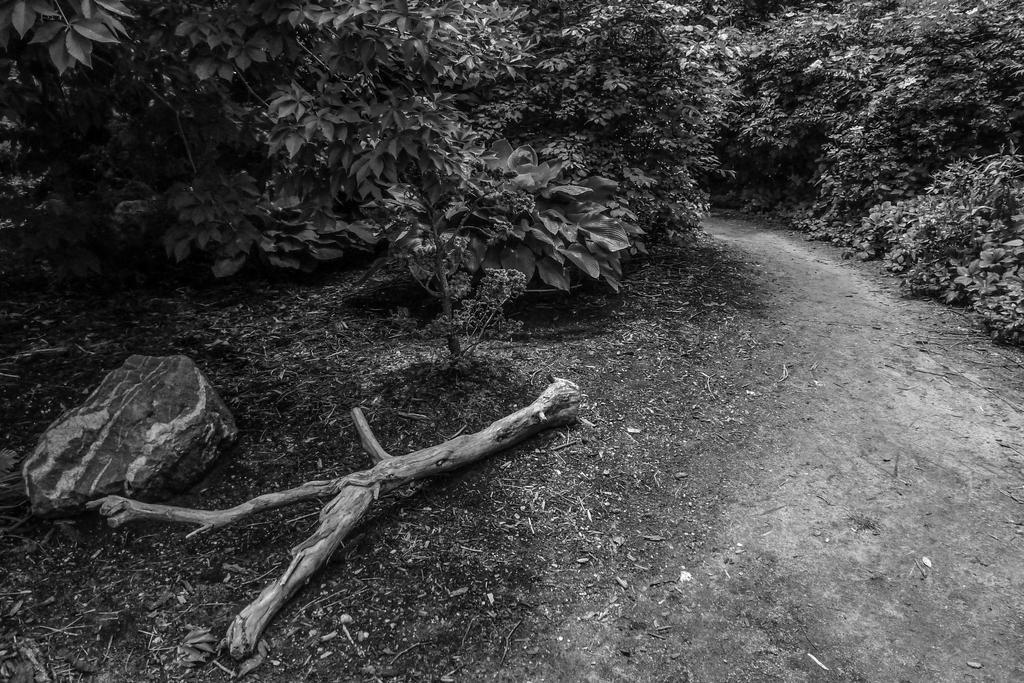Please provide a concise description of this image. In the middle of the image we can see some trees. In the bottom left corner of the image we can see a stem and stone. 